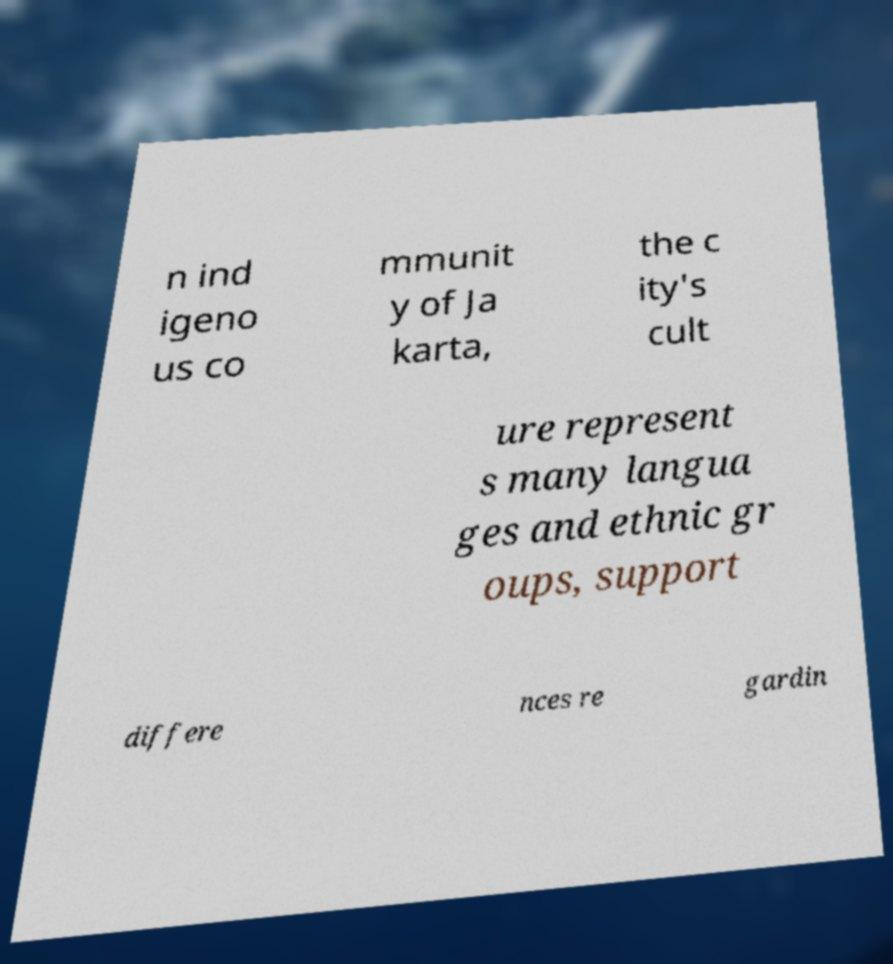Could you extract and type out the text from this image? n ind igeno us co mmunit y of Ja karta, the c ity's cult ure represent s many langua ges and ethnic gr oups, support differe nces re gardin 